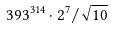<formula> <loc_0><loc_0><loc_500><loc_500>3 9 3 ^ { 3 1 4 } \cdot 2 ^ { 7 } / \sqrt { 1 0 }</formula> 